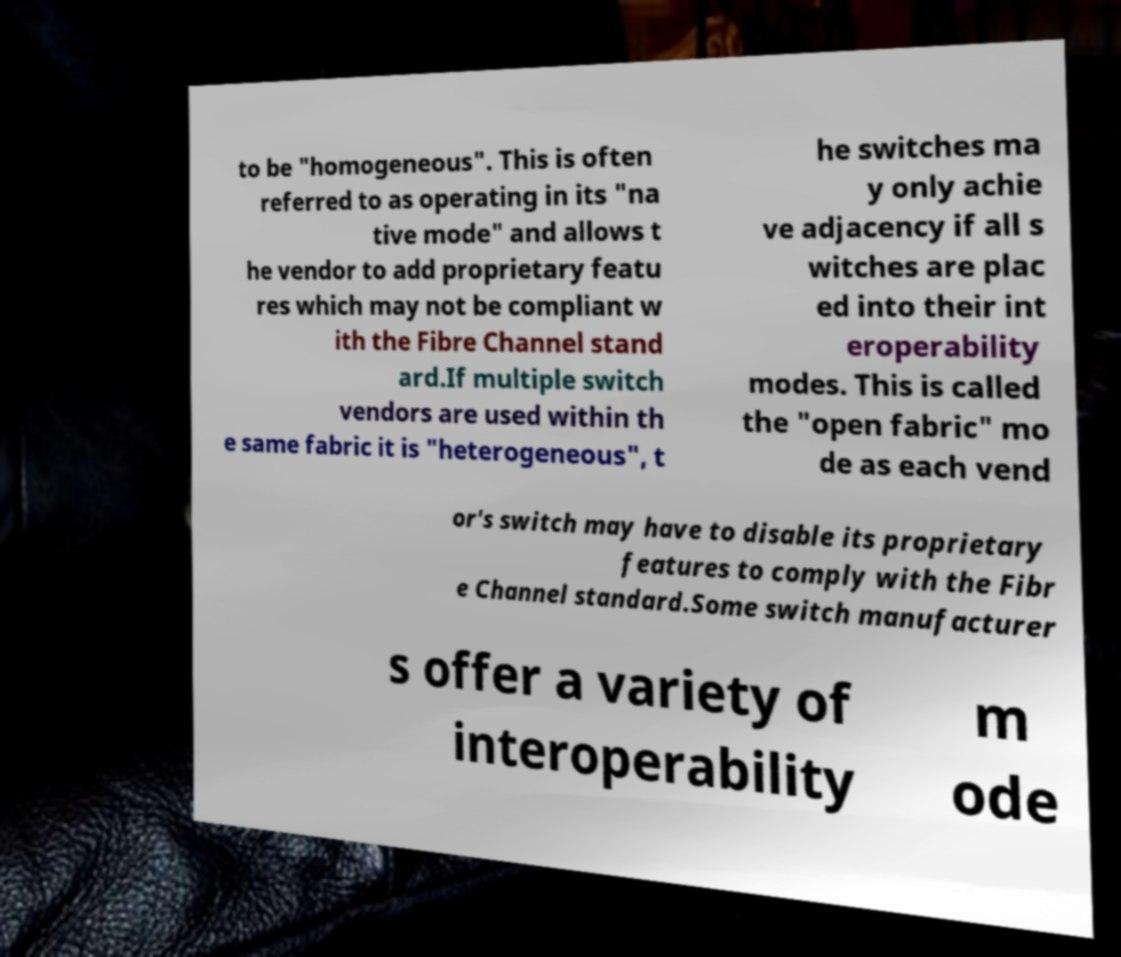Can you accurately transcribe the text from the provided image for me? to be "homogeneous". This is often referred to as operating in its "na tive mode" and allows t he vendor to add proprietary featu res which may not be compliant w ith the Fibre Channel stand ard.If multiple switch vendors are used within th e same fabric it is "heterogeneous", t he switches ma y only achie ve adjacency if all s witches are plac ed into their int eroperability modes. This is called the "open fabric" mo de as each vend or's switch may have to disable its proprietary features to comply with the Fibr e Channel standard.Some switch manufacturer s offer a variety of interoperability m ode 